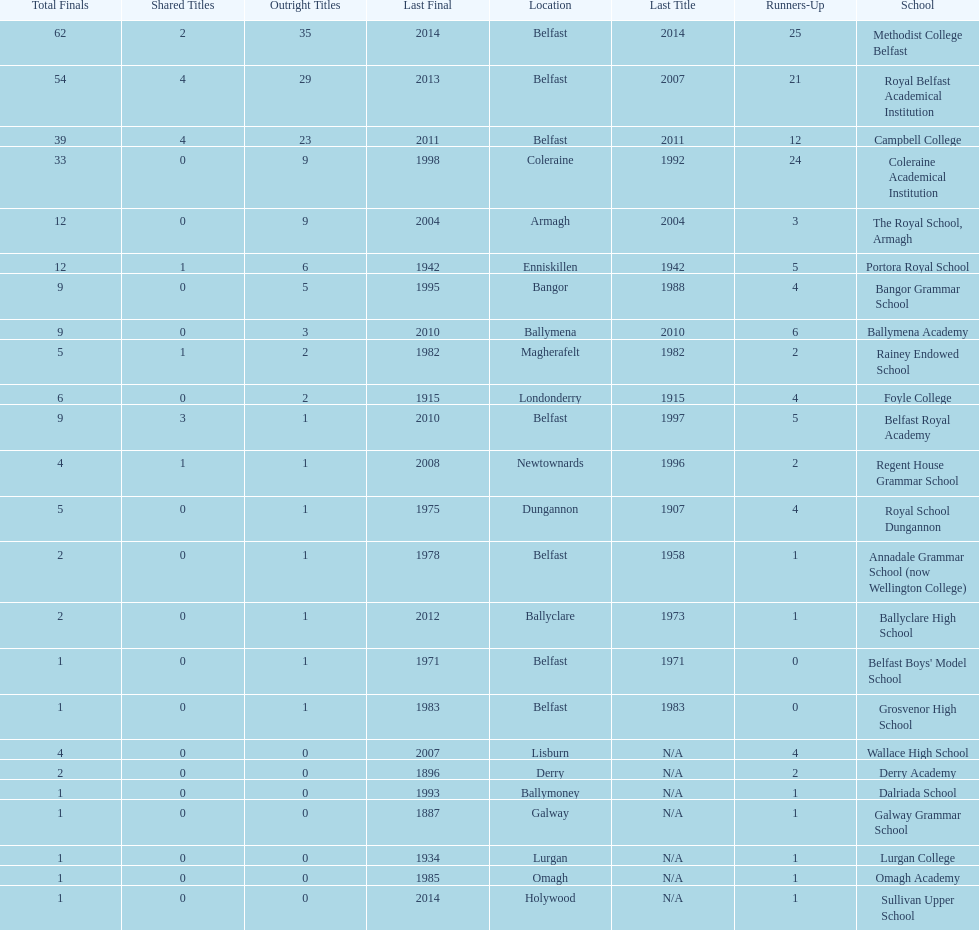What is the difference in runners-up from coleraine academical institution and royal school dungannon? 20. 